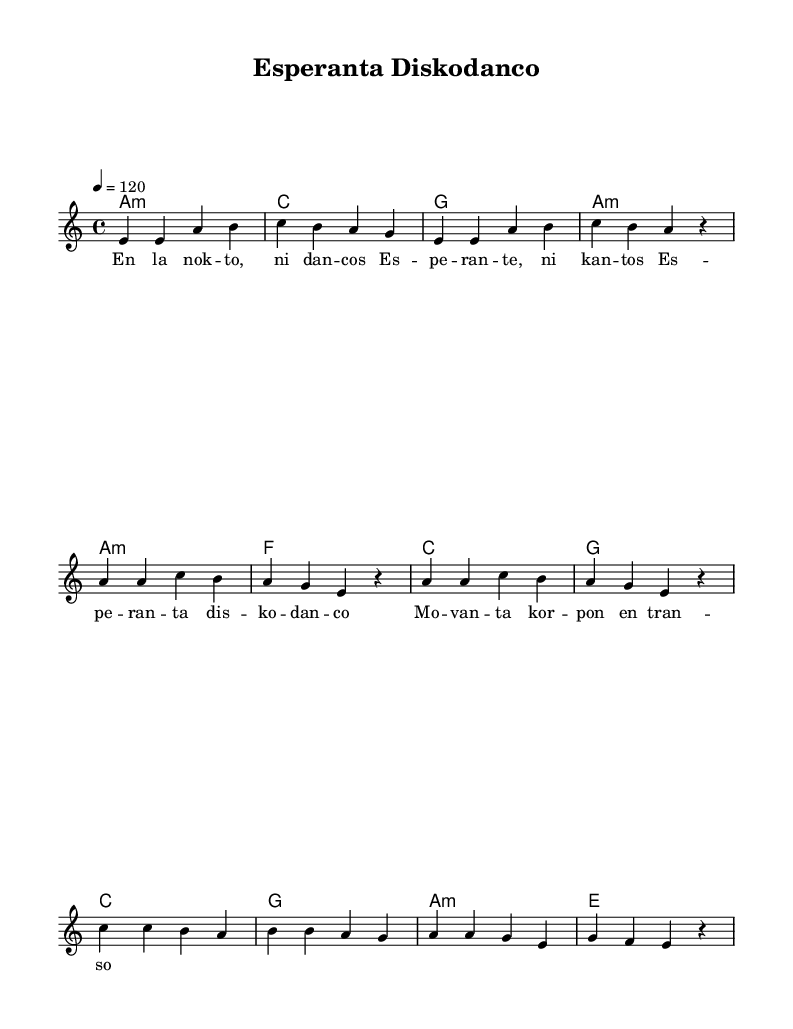What is the key signature of this music? The key signature in the piece is A minor, which is indicated by the key signature shown at the beginning of the score. A minor has no sharps or flats.
Answer: A minor What is the time signature of this music? The time signature is noted as 4/4 at the beginning of the score, which indicates that there are four beats in each measure and the quarter note gets one beat.
Answer: 4/4 What is the tempo marking given in the score? The tempo marking displayed is "4 = 120", meaning that there are 120 beats per minute. This indicates a moderate tempo for the piece.
Answer: 120 How many measures are in the Verse section? The Verse section consists of 8 measures, which can be counted by looking at the distinct groupings of four beats each within the melody part of the score.
Answer: 8 What type of harmony is primarily used in this piece? The score uses a combination of minor and major harmonies, specifically A minor and C major chords, typical of disco music, which often features rich harmonic progressions.
Answer: Minor and major What is the primary lyrical language of this piece? The lyrics are clearly in Esperanto, as evidenced by the text shown beneath the melody which features words structured in Esperanto language patterns.
Answer: Esperanto What thematic focus does the chorus express? The chorus emphasizes the joy and movement of disco dancing, as indicated by the lyrics "Esperanta diskodanco" which translates to "Esperanto disco dance."
Answer: Disco dancing 